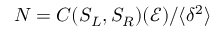<formula> <loc_0><loc_0><loc_500><loc_500>N = C ( S _ { L } , S _ { R } ) ( \mathcal { E } ) / \langle \delta ^ { 2 } \rangle</formula> 